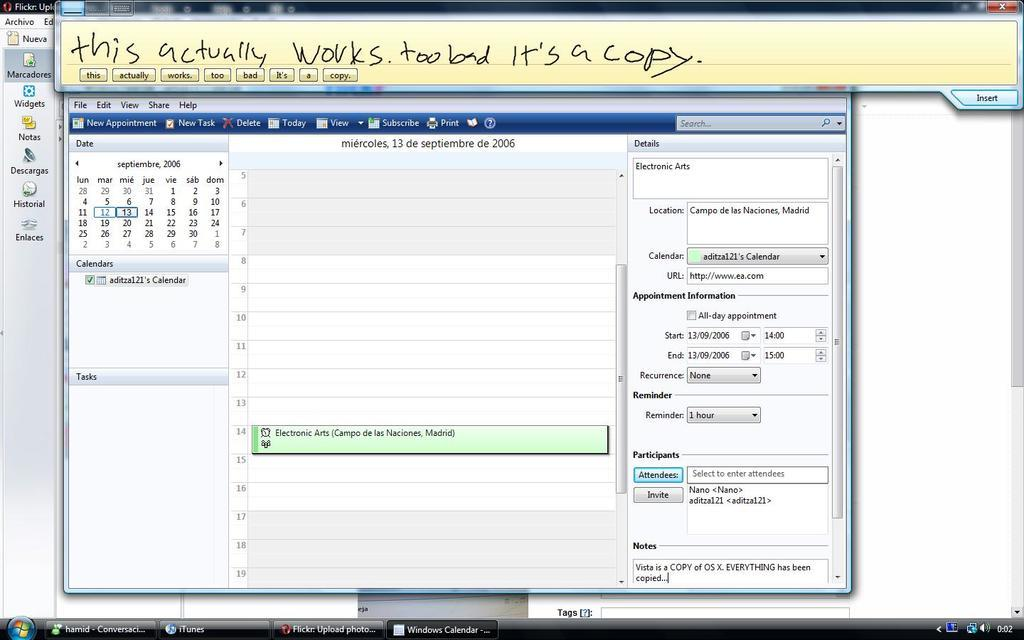<image>
Write a terse but informative summary of the picture. A screen shot with a note that reads "works. too bad it's a copy 